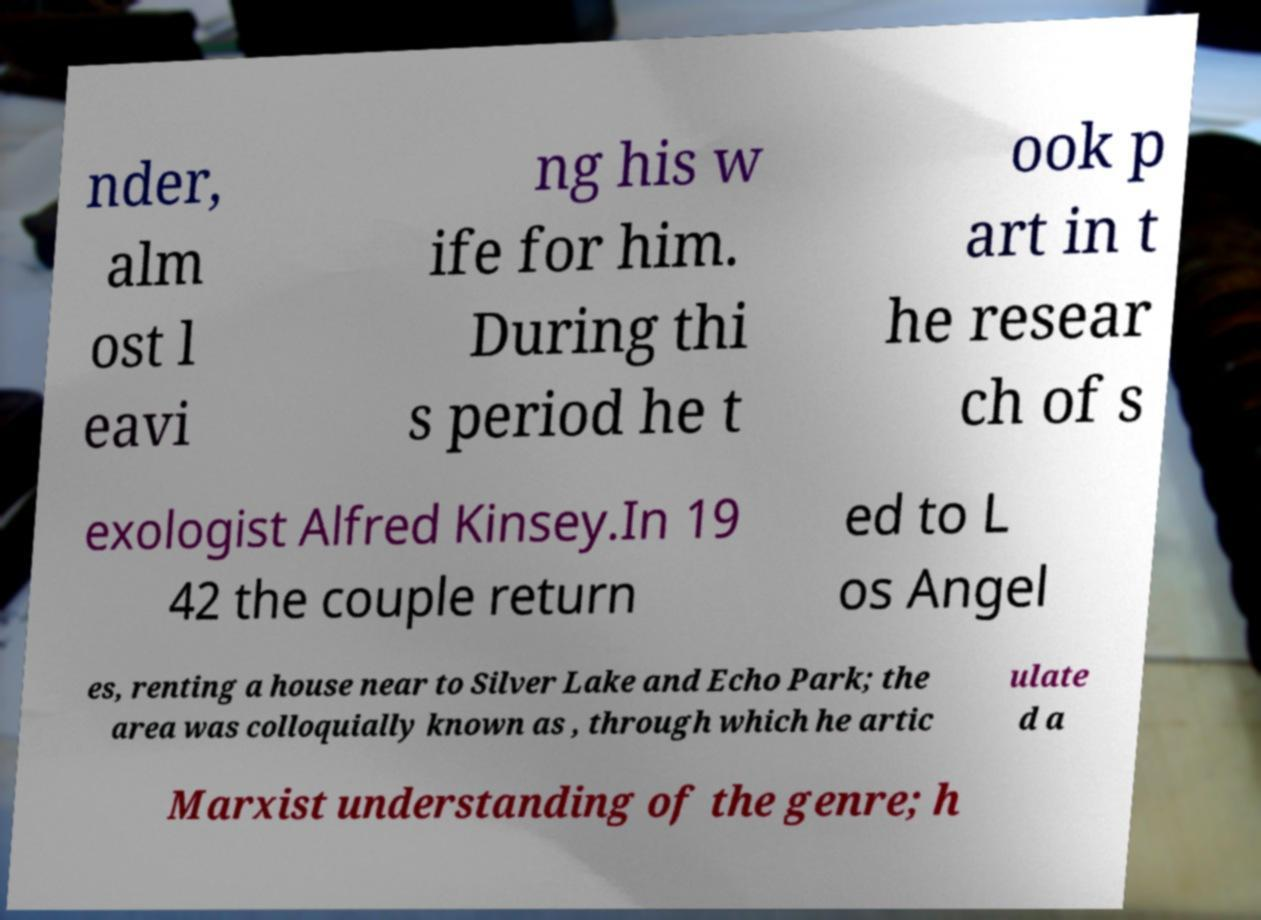Please identify and transcribe the text found in this image. nder, alm ost l eavi ng his w ife for him. During thi s period he t ook p art in t he resear ch of s exologist Alfred Kinsey.In 19 42 the couple return ed to L os Angel es, renting a house near to Silver Lake and Echo Park; the area was colloquially known as , through which he artic ulate d a Marxist understanding of the genre; h 